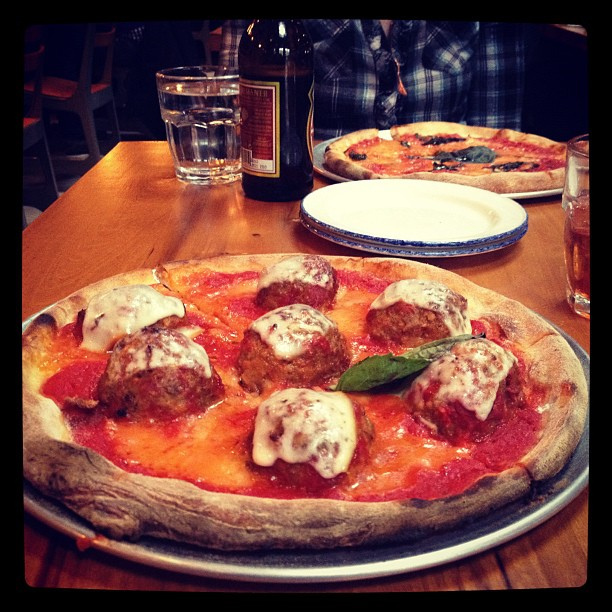<image>How many people are dining? I am not sure how many people are dining. It can be seen 1, 2 or 6. How many people are dining? I don't know how many people are dining. But it can be seen that there are at least 2 people. 